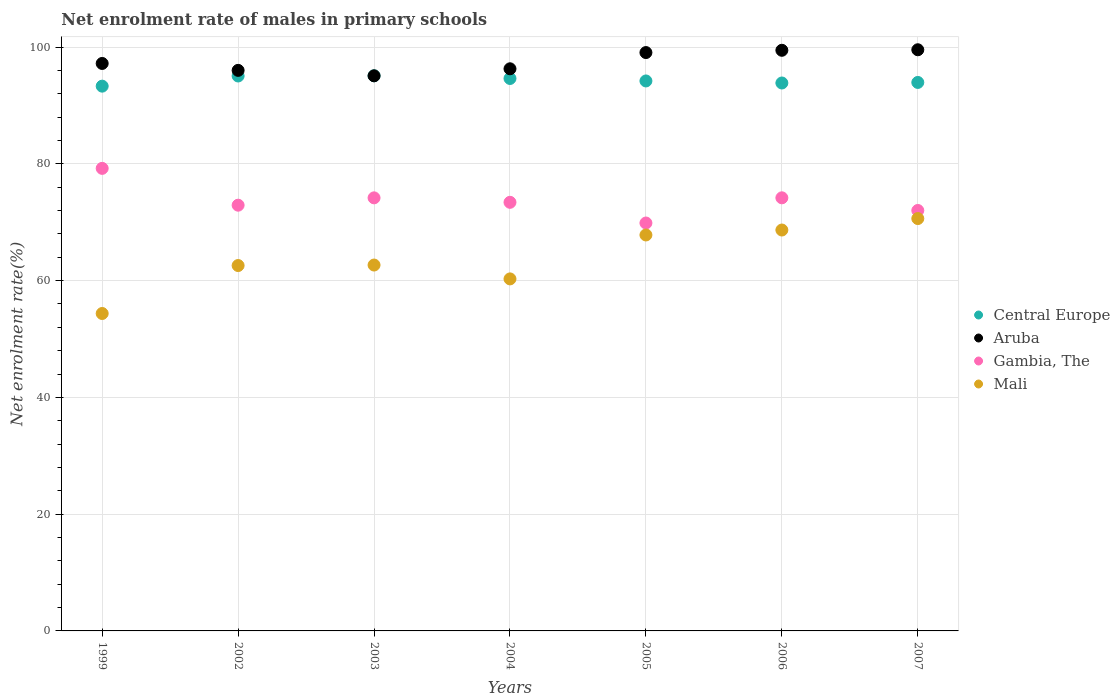Is the number of dotlines equal to the number of legend labels?
Give a very brief answer. Yes. What is the net enrolment rate of males in primary schools in Central Europe in 1999?
Ensure brevity in your answer.  93.31. Across all years, what is the maximum net enrolment rate of males in primary schools in Gambia, The?
Give a very brief answer. 79.23. Across all years, what is the minimum net enrolment rate of males in primary schools in Mali?
Keep it short and to the point. 54.37. In which year was the net enrolment rate of males in primary schools in Central Europe maximum?
Your response must be concise. 2003. In which year was the net enrolment rate of males in primary schools in Gambia, The minimum?
Your answer should be very brief. 2005. What is the total net enrolment rate of males in primary schools in Aruba in the graph?
Offer a terse response. 682.65. What is the difference between the net enrolment rate of males in primary schools in Mali in 2005 and that in 2007?
Provide a succinct answer. -2.81. What is the difference between the net enrolment rate of males in primary schools in Central Europe in 2004 and the net enrolment rate of males in primary schools in Aruba in 2002?
Provide a succinct answer. -1.39. What is the average net enrolment rate of males in primary schools in Gambia, The per year?
Make the answer very short. 73.69. In the year 2004, what is the difference between the net enrolment rate of males in primary schools in Mali and net enrolment rate of males in primary schools in Aruba?
Make the answer very short. -35.99. In how many years, is the net enrolment rate of males in primary schools in Gambia, The greater than 84 %?
Make the answer very short. 0. What is the ratio of the net enrolment rate of males in primary schools in Aruba in 1999 to that in 2006?
Your answer should be compact. 0.98. What is the difference between the highest and the second highest net enrolment rate of males in primary schools in Gambia, The?
Your response must be concise. 5.04. What is the difference between the highest and the lowest net enrolment rate of males in primary schools in Gambia, The?
Keep it short and to the point. 9.36. In how many years, is the net enrolment rate of males in primary schools in Gambia, The greater than the average net enrolment rate of males in primary schools in Gambia, The taken over all years?
Your response must be concise. 3. Is the sum of the net enrolment rate of males in primary schools in Gambia, The in 1999 and 2007 greater than the maximum net enrolment rate of males in primary schools in Central Europe across all years?
Give a very brief answer. Yes. Is it the case that in every year, the sum of the net enrolment rate of males in primary schools in Central Europe and net enrolment rate of males in primary schools in Mali  is greater than the net enrolment rate of males in primary schools in Aruba?
Your answer should be very brief. Yes. How many dotlines are there?
Offer a terse response. 4. How many years are there in the graph?
Your answer should be very brief. 7. What is the difference between two consecutive major ticks on the Y-axis?
Ensure brevity in your answer.  20. Does the graph contain grids?
Keep it short and to the point. Yes. Where does the legend appear in the graph?
Your answer should be compact. Center right. How are the legend labels stacked?
Your answer should be compact. Vertical. What is the title of the graph?
Give a very brief answer. Net enrolment rate of males in primary schools. Does "Liberia" appear as one of the legend labels in the graph?
Your answer should be very brief. No. What is the label or title of the Y-axis?
Provide a succinct answer. Net enrolment rate(%). What is the Net enrolment rate(%) in Central Europe in 1999?
Your answer should be compact. 93.31. What is the Net enrolment rate(%) of Aruba in 1999?
Offer a very short reply. 97.2. What is the Net enrolment rate(%) in Gambia, The in 1999?
Offer a very short reply. 79.23. What is the Net enrolment rate(%) of Mali in 1999?
Your answer should be very brief. 54.37. What is the Net enrolment rate(%) in Central Europe in 2002?
Your answer should be compact. 95.05. What is the Net enrolment rate(%) in Aruba in 2002?
Offer a very short reply. 96.02. What is the Net enrolment rate(%) of Gambia, The in 2002?
Provide a succinct answer. 72.92. What is the Net enrolment rate(%) of Mali in 2002?
Keep it short and to the point. 62.59. What is the Net enrolment rate(%) of Central Europe in 2003?
Ensure brevity in your answer.  95.09. What is the Net enrolment rate(%) of Aruba in 2003?
Your answer should be very brief. 95.08. What is the Net enrolment rate(%) in Gambia, The in 2003?
Ensure brevity in your answer.  74.18. What is the Net enrolment rate(%) of Mali in 2003?
Provide a succinct answer. 62.67. What is the Net enrolment rate(%) in Central Europe in 2004?
Provide a short and direct response. 94.63. What is the Net enrolment rate(%) in Aruba in 2004?
Make the answer very short. 96.29. What is the Net enrolment rate(%) of Gambia, The in 2004?
Keep it short and to the point. 73.42. What is the Net enrolment rate(%) in Mali in 2004?
Give a very brief answer. 60.3. What is the Net enrolment rate(%) in Central Europe in 2005?
Offer a terse response. 94.2. What is the Net enrolment rate(%) in Aruba in 2005?
Provide a short and direct response. 99.07. What is the Net enrolment rate(%) in Gambia, The in 2005?
Keep it short and to the point. 69.87. What is the Net enrolment rate(%) of Mali in 2005?
Your answer should be very brief. 67.82. What is the Net enrolment rate(%) in Central Europe in 2006?
Make the answer very short. 93.85. What is the Net enrolment rate(%) in Aruba in 2006?
Your response must be concise. 99.46. What is the Net enrolment rate(%) in Gambia, The in 2006?
Keep it short and to the point. 74.18. What is the Net enrolment rate(%) in Mali in 2006?
Keep it short and to the point. 68.67. What is the Net enrolment rate(%) of Central Europe in 2007?
Make the answer very short. 93.95. What is the Net enrolment rate(%) in Aruba in 2007?
Your answer should be very brief. 99.55. What is the Net enrolment rate(%) of Gambia, The in 2007?
Offer a very short reply. 72.02. What is the Net enrolment rate(%) of Mali in 2007?
Provide a short and direct response. 70.63. Across all years, what is the maximum Net enrolment rate(%) in Central Europe?
Offer a very short reply. 95.09. Across all years, what is the maximum Net enrolment rate(%) of Aruba?
Offer a terse response. 99.55. Across all years, what is the maximum Net enrolment rate(%) in Gambia, The?
Give a very brief answer. 79.23. Across all years, what is the maximum Net enrolment rate(%) of Mali?
Your response must be concise. 70.63. Across all years, what is the minimum Net enrolment rate(%) of Central Europe?
Your answer should be compact. 93.31. Across all years, what is the minimum Net enrolment rate(%) in Aruba?
Your answer should be very brief. 95.08. Across all years, what is the minimum Net enrolment rate(%) of Gambia, The?
Your response must be concise. 69.87. Across all years, what is the minimum Net enrolment rate(%) of Mali?
Offer a terse response. 54.37. What is the total Net enrolment rate(%) of Central Europe in the graph?
Make the answer very short. 660.09. What is the total Net enrolment rate(%) of Aruba in the graph?
Provide a succinct answer. 682.65. What is the total Net enrolment rate(%) in Gambia, The in the graph?
Offer a very short reply. 515.82. What is the total Net enrolment rate(%) in Mali in the graph?
Keep it short and to the point. 447.05. What is the difference between the Net enrolment rate(%) in Central Europe in 1999 and that in 2002?
Offer a terse response. -1.74. What is the difference between the Net enrolment rate(%) in Aruba in 1999 and that in 2002?
Offer a very short reply. 1.18. What is the difference between the Net enrolment rate(%) of Gambia, The in 1999 and that in 2002?
Your answer should be compact. 6.31. What is the difference between the Net enrolment rate(%) of Mali in 1999 and that in 2002?
Provide a short and direct response. -8.21. What is the difference between the Net enrolment rate(%) of Central Europe in 1999 and that in 2003?
Your answer should be very brief. -1.77. What is the difference between the Net enrolment rate(%) of Aruba in 1999 and that in 2003?
Ensure brevity in your answer.  2.12. What is the difference between the Net enrolment rate(%) in Gambia, The in 1999 and that in 2003?
Provide a short and direct response. 5.05. What is the difference between the Net enrolment rate(%) of Central Europe in 1999 and that in 2004?
Give a very brief answer. -1.32. What is the difference between the Net enrolment rate(%) in Aruba in 1999 and that in 2004?
Offer a very short reply. 0.91. What is the difference between the Net enrolment rate(%) of Gambia, The in 1999 and that in 2004?
Keep it short and to the point. 5.81. What is the difference between the Net enrolment rate(%) in Mali in 1999 and that in 2004?
Offer a very short reply. -5.93. What is the difference between the Net enrolment rate(%) of Central Europe in 1999 and that in 2005?
Offer a terse response. -0.89. What is the difference between the Net enrolment rate(%) of Aruba in 1999 and that in 2005?
Your answer should be compact. -1.87. What is the difference between the Net enrolment rate(%) of Gambia, The in 1999 and that in 2005?
Give a very brief answer. 9.36. What is the difference between the Net enrolment rate(%) of Mali in 1999 and that in 2005?
Your answer should be very brief. -13.45. What is the difference between the Net enrolment rate(%) in Central Europe in 1999 and that in 2006?
Provide a short and direct response. -0.54. What is the difference between the Net enrolment rate(%) in Aruba in 1999 and that in 2006?
Offer a very short reply. -2.25. What is the difference between the Net enrolment rate(%) of Gambia, The in 1999 and that in 2006?
Your answer should be compact. 5.04. What is the difference between the Net enrolment rate(%) in Mali in 1999 and that in 2006?
Your answer should be very brief. -14.3. What is the difference between the Net enrolment rate(%) in Central Europe in 1999 and that in 2007?
Offer a terse response. -0.64. What is the difference between the Net enrolment rate(%) of Aruba in 1999 and that in 2007?
Offer a very short reply. -2.35. What is the difference between the Net enrolment rate(%) in Gambia, The in 1999 and that in 2007?
Your response must be concise. 7.21. What is the difference between the Net enrolment rate(%) in Mali in 1999 and that in 2007?
Ensure brevity in your answer.  -16.26. What is the difference between the Net enrolment rate(%) of Central Europe in 2002 and that in 2003?
Your response must be concise. -0.03. What is the difference between the Net enrolment rate(%) of Aruba in 2002 and that in 2003?
Your answer should be compact. 0.94. What is the difference between the Net enrolment rate(%) in Gambia, The in 2002 and that in 2003?
Ensure brevity in your answer.  -1.26. What is the difference between the Net enrolment rate(%) of Mali in 2002 and that in 2003?
Your answer should be compact. -0.09. What is the difference between the Net enrolment rate(%) of Central Europe in 2002 and that in 2004?
Provide a short and direct response. 0.42. What is the difference between the Net enrolment rate(%) in Aruba in 2002 and that in 2004?
Keep it short and to the point. -0.27. What is the difference between the Net enrolment rate(%) in Gambia, The in 2002 and that in 2004?
Offer a very short reply. -0.49. What is the difference between the Net enrolment rate(%) of Mali in 2002 and that in 2004?
Offer a terse response. 2.29. What is the difference between the Net enrolment rate(%) in Central Europe in 2002 and that in 2005?
Ensure brevity in your answer.  0.85. What is the difference between the Net enrolment rate(%) of Aruba in 2002 and that in 2005?
Your response must be concise. -3.05. What is the difference between the Net enrolment rate(%) in Gambia, The in 2002 and that in 2005?
Your answer should be compact. 3.05. What is the difference between the Net enrolment rate(%) of Mali in 2002 and that in 2005?
Ensure brevity in your answer.  -5.24. What is the difference between the Net enrolment rate(%) of Central Europe in 2002 and that in 2006?
Provide a succinct answer. 1.2. What is the difference between the Net enrolment rate(%) of Aruba in 2002 and that in 2006?
Keep it short and to the point. -3.44. What is the difference between the Net enrolment rate(%) in Gambia, The in 2002 and that in 2006?
Make the answer very short. -1.26. What is the difference between the Net enrolment rate(%) of Mali in 2002 and that in 2006?
Your answer should be very brief. -6.08. What is the difference between the Net enrolment rate(%) in Central Europe in 2002 and that in 2007?
Provide a succinct answer. 1.1. What is the difference between the Net enrolment rate(%) in Aruba in 2002 and that in 2007?
Provide a succinct answer. -3.53. What is the difference between the Net enrolment rate(%) of Gambia, The in 2002 and that in 2007?
Your answer should be compact. 0.91. What is the difference between the Net enrolment rate(%) of Mali in 2002 and that in 2007?
Your response must be concise. -8.05. What is the difference between the Net enrolment rate(%) in Central Europe in 2003 and that in 2004?
Offer a very short reply. 0.46. What is the difference between the Net enrolment rate(%) of Aruba in 2003 and that in 2004?
Your answer should be compact. -1.21. What is the difference between the Net enrolment rate(%) in Gambia, The in 2003 and that in 2004?
Your answer should be compact. 0.76. What is the difference between the Net enrolment rate(%) in Mali in 2003 and that in 2004?
Provide a short and direct response. 2.37. What is the difference between the Net enrolment rate(%) in Central Europe in 2003 and that in 2005?
Offer a very short reply. 0.88. What is the difference between the Net enrolment rate(%) of Aruba in 2003 and that in 2005?
Ensure brevity in your answer.  -3.99. What is the difference between the Net enrolment rate(%) of Gambia, The in 2003 and that in 2005?
Your response must be concise. 4.31. What is the difference between the Net enrolment rate(%) in Mali in 2003 and that in 2005?
Ensure brevity in your answer.  -5.15. What is the difference between the Net enrolment rate(%) of Central Europe in 2003 and that in 2006?
Your answer should be very brief. 1.23. What is the difference between the Net enrolment rate(%) of Aruba in 2003 and that in 2006?
Your response must be concise. -4.37. What is the difference between the Net enrolment rate(%) of Gambia, The in 2003 and that in 2006?
Ensure brevity in your answer.  -0.01. What is the difference between the Net enrolment rate(%) in Mali in 2003 and that in 2006?
Offer a very short reply. -6. What is the difference between the Net enrolment rate(%) of Central Europe in 2003 and that in 2007?
Provide a succinct answer. 1.14. What is the difference between the Net enrolment rate(%) of Aruba in 2003 and that in 2007?
Provide a short and direct response. -4.46. What is the difference between the Net enrolment rate(%) of Gambia, The in 2003 and that in 2007?
Offer a terse response. 2.16. What is the difference between the Net enrolment rate(%) of Mali in 2003 and that in 2007?
Your answer should be very brief. -7.96. What is the difference between the Net enrolment rate(%) in Central Europe in 2004 and that in 2005?
Provide a succinct answer. 0.42. What is the difference between the Net enrolment rate(%) of Aruba in 2004 and that in 2005?
Ensure brevity in your answer.  -2.78. What is the difference between the Net enrolment rate(%) of Gambia, The in 2004 and that in 2005?
Your answer should be very brief. 3.54. What is the difference between the Net enrolment rate(%) of Mali in 2004 and that in 2005?
Provide a succinct answer. -7.52. What is the difference between the Net enrolment rate(%) of Central Europe in 2004 and that in 2006?
Offer a terse response. 0.77. What is the difference between the Net enrolment rate(%) of Aruba in 2004 and that in 2006?
Your answer should be very brief. -3.17. What is the difference between the Net enrolment rate(%) in Gambia, The in 2004 and that in 2006?
Your answer should be compact. -0.77. What is the difference between the Net enrolment rate(%) of Mali in 2004 and that in 2006?
Provide a succinct answer. -8.37. What is the difference between the Net enrolment rate(%) in Central Europe in 2004 and that in 2007?
Your answer should be compact. 0.68. What is the difference between the Net enrolment rate(%) in Aruba in 2004 and that in 2007?
Your answer should be compact. -3.26. What is the difference between the Net enrolment rate(%) of Gambia, The in 2004 and that in 2007?
Offer a terse response. 1.4. What is the difference between the Net enrolment rate(%) in Mali in 2004 and that in 2007?
Provide a succinct answer. -10.34. What is the difference between the Net enrolment rate(%) of Central Europe in 2005 and that in 2006?
Provide a short and direct response. 0.35. What is the difference between the Net enrolment rate(%) of Aruba in 2005 and that in 2006?
Ensure brevity in your answer.  -0.39. What is the difference between the Net enrolment rate(%) of Gambia, The in 2005 and that in 2006?
Your answer should be compact. -4.31. What is the difference between the Net enrolment rate(%) of Mali in 2005 and that in 2006?
Keep it short and to the point. -0.85. What is the difference between the Net enrolment rate(%) of Central Europe in 2005 and that in 2007?
Keep it short and to the point. 0.26. What is the difference between the Net enrolment rate(%) in Aruba in 2005 and that in 2007?
Your answer should be very brief. -0.48. What is the difference between the Net enrolment rate(%) of Gambia, The in 2005 and that in 2007?
Provide a short and direct response. -2.15. What is the difference between the Net enrolment rate(%) in Mali in 2005 and that in 2007?
Keep it short and to the point. -2.81. What is the difference between the Net enrolment rate(%) of Central Europe in 2006 and that in 2007?
Offer a very short reply. -0.09. What is the difference between the Net enrolment rate(%) in Aruba in 2006 and that in 2007?
Your answer should be compact. -0.09. What is the difference between the Net enrolment rate(%) in Gambia, The in 2006 and that in 2007?
Keep it short and to the point. 2.17. What is the difference between the Net enrolment rate(%) in Mali in 2006 and that in 2007?
Provide a succinct answer. -1.96. What is the difference between the Net enrolment rate(%) of Central Europe in 1999 and the Net enrolment rate(%) of Aruba in 2002?
Keep it short and to the point. -2.7. What is the difference between the Net enrolment rate(%) of Central Europe in 1999 and the Net enrolment rate(%) of Gambia, The in 2002?
Your response must be concise. 20.39. What is the difference between the Net enrolment rate(%) in Central Europe in 1999 and the Net enrolment rate(%) in Mali in 2002?
Your response must be concise. 30.73. What is the difference between the Net enrolment rate(%) of Aruba in 1999 and the Net enrolment rate(%) of Gambia, The in 2002?
Keep it short and to the point. 24.28. What is the difference between the Net enrolment rate(%) in Aruba in 1999 and the Net enrolment rate(%) in Mali in 2002?
Your response must be concise. 34.61. What is the difference between the Net enrolment rate(%) in Gambia, The in 1999 and the Net enrolment rate(%) in Mali in 2002?
Provide a succinct answer. 16.64. What is the difference between the Net enrolment rate(%) of Central Europe in 1999 and the Net enrolment rate(%) of Aruba in 2003?
Keep it short and to the point. -1.77. What is the difference between the Net enrolment rate(%) in Central Europe in 1999 and the Net enrolment rate(%) in Gambia, The in 2003?
Provide a succinct answer. 19.13. What is the difference between the Net enrolment rate(%) in Central Europe in 1999 and the Net enrolment rate(%) in Mali in 2003?
Keep it short and to the point. 30.64. What is the difference between the Net enrolment rate(%) in Aruba in 1999 and the Net enrolment rate(%) in Gambia, The in 2003?
Ensure brevity in your answer.  23.02. What is the difference between the Net enrolment rate(%) in Aruba in 1999 and the Net enrolment rate(%) in Mali in 2003?
Keep it short and to the point. 34.53. What is the difference between the Net enrolment rate(%) in Gambia, The in 1999 and the Net enrolment rate(%) in Mali in 2003?
Your answer should be compact. 16.56. What is the difference between the Net enrolment rate(%) in Central Europe in 1999 and the Net enrolment rate(%) in Aruba in 2004?
Keep it short and to the point. -2.97. What is the difference between the Net enrolment rate(%) in Central Europe in 1999 and the Net enrolment rate(%) in Gambia, The in 2004?
Offer a terse response. 19.9. What is the difference between the Net enrolment rate(%) in Central Europe in 1999 and the Net enrolment rate(%) in Mali in 2004?
Keep it short and to the point. 33.01. What is the difference between the Net enrolment rate(%) in Aruba in 1999 and the Net enrolment rate(%) in Gambia, The in 2004?
Your answer should be compact. 23.79. What is the difference between the Net enrolment rate(%) in Aruba in 1999 and the Net enrolment rate(%) in Mali in 2004?
Provide a short and direct response. 36.9. What is the difference between the Net enrolment rate(%) of Gambia, The in 1999 and the Net enrolment rate(%) of Mali in 2004?
Provide a succinct answer. 18.93. What is the difference between the Net enrolment rate(%) of Central Europe in 1999 and the Net enrolment rate(%) of Aruba in 2005?
Keep it short and to the point. -5.75. What is the difference between the Net enrolment rate(%) of Central Europe in 1999 and the Net enrolment rate(%) of Gambia, The in 2005?
Provide a succinct answer. 23.44. What is the difference between the Net enrolment rate(%) in Central Europe in 1999 and the Net enrolment rate(%) in Mali in 2005?
Provide a succinct answer. 25.49. What is the difference between the Net enrolment rate(%) of Aruba in 1999 and the Net enrolment rate(%) of Gambia, The in 2005?
Provide a short and direct response. 27.33. What is the difference between the Net enrolment rate(%) in Aruba in 1999 and the Net enrolment rate(%) in Mali in 2005?
Give a very brief answer. 29.38. What is the difference between the Net enrolment rate(%) in Gambia, The in 1999 and the Net enrolment rate(%) in Mali in 2005?
Make the answer very short. 11.41. What is the difference between the Net enrolment rate(%) of Central Europe in 1999 and the Net enrolment rate(%) of Aruba in 2006?
Keep it short and to the point. -6.14. What is the difference between the Net enrolment rate(%) in Central Europe in 1999 and the Net enrolment rate(%) in Gambia, The in 2006?
Your answer should be very brief. 19.13. What is the difference between the Net enrolment rate(%) in Central Europe in 1999 and the Net enrolment rate(%) in Mali in 2006?
Ensure brevity in your answer.  24.64. What is the difference between the Net enrolment rate(%) of Aruba in 1999 and the Net enrolment rate(%) of Gambia, The in 2006?
Provide a succinct answer. 23.02. What is the difference between the Net enrolment rate(%) of Aruba in 1999 and the Net enrolment rate(%) of Mali in 2006?
Your response must be concise. 28.53. What is the difference between the Net enrolment rate(%) in Gambia, The in 1999 and the Net enrolment rate(%) in Mali in 2006?
Your response must be concise. 10.56. What is the difference between the Net enrolment rate(%) in Central Europe in 1999 and the Net enrolment rate(%) in Aruba in 2007?
Your response must be concise. -6.23. What is the difference between the Net enrolment rate(%) of Central Europe in 1999 and the Net enrolment rate(%) of Gambia, The in 2007?
Keep it short and to the point. 21.29. What is the difference between the Net enrolment rate(%) in Central Europe in 1999 and the Net enrolment rate(%) in Mali in 2007?
Your response must be concise. 22.68. What is the difference between the Net enrolment rate(%) in Aruba in 1999 and the Net enrolment rate(%) in Gambia, The in 2007?
Offer a terse response. 25.18. What is the difference between the Net enrolment rate(%) in Aruba in 1999 and the Net enrolment rate(%) in Mali in 2007?
Keep it short and to the point. 26.57. What is the difference between the Net enrolment rate(%) in Gambia, The in 1999 and the Net enrolment rate(%) in Mali in 2007?
Give a very brief answer. 8.6. What is the difference between the Net enrolment rate(%) of Central Europe in 2002 and the Net enrolment rate(%) of Aruba in 2003?
Ensure brevity in your answer.  -0.03. What is the difference between the Net enrolment rate(%) of Central Europe in 2002 and the Net enrolment rate(%) of Gambia, The in 2003?
Make the answer very short. 20.87. What is the difference between the Net enrolment rate(%) of Central Europe in 2002 and the Net enrolment rate(%) of Mali in 2003?
Your answer should be compact. 32.38. What is the difference between the Net enrolment rate(%) of Aruba in 2002 and the Net enrolment rate(%) of Gambia, The in 2003?
Keep it short and to the point. 21.84. What is the difference between the Net enrolment rate(%) of Aruba in 2002 and the Net enrolment rate(%) of Mali in 2003?
Keep it short and to the point. 33.35. What is the difference between the Net enrolment rate(%) of Gambia, The in 2002 and the Net enrolment rate(%) of Mali in 2003?
Make the answer very short. 10.25. What is the difference between the Net enrolment rate(%) in Central Europe in 2002 and the Net enrolment rate(%) in Aruba in 2004?
Keep it short and to the point. -1.23. What is the difference between the Net enrolment rate(%) in Central Europe in 2002 and the Net enrolment rate(%) in Gambia, The in 2004?
Your answer should be compact. 21.64. What is the difference between the Net enrolment rate(%) of Central Europe in 2002 and the Net enrolment rate(%) of Mali in 2004?
Provide a short and direct response. 34.75. What is the difference between the Net enrolment rate(%) in Aruba in 2002 and the Net enrolment rate(%) in Gambia, The in 2004?
Offer a terse response. 22.6. What is the difference between the Net enrolment rate(%) in Aruba in 2002 and the Net enrolment rate(%) in Mali in 2004?
Your response must be concise. 35.72. What is the difference between the Net enrolment rate(%) in Gambia, The in 2002 and the Net enrolment rate(%) in Mali in 2004?
Offer a very short reply. 12.62. What is the difference between the Net enrolment rate(%) in Central Europe in 2002 and the Net enrolment rate(%) in Aruba in 2005?
Your response must be concise. -4.01. What is the difference between the Net enrolment rate(%) in Central Europe in 2002 and the Net enrolment rate(%) in Gambia, The in 2005?
Provide a short and direct response. 25.18. What is the difference between the Net enrolment rate(%) of Central Europe in 2002 and the Net enrolment rate(%) of Mali in 2005?
Ensure brevity in your answer.  27.23. What is the difference between the Net enrolment rate(%) of Aruba in 2002 and the Net enrolment rate(%) of Gambia, The in 2005?
Make the answer very short. 26.15. What is the difference between the Net enrolment rate(%) of Aruba in 2002 and the Net enrolment rate(%) of Mali in 2005?
Your answer should be very brief. 28.2. What is the difference between the Net enrolment rate(%) of Gambia, The in 2002 and the Net enrolment rate(%) of Mali in 2005?
Offer a terse response. 5.1. What is the difference between the Net enrolment rate(%) in Central Europe in 2002 and the Net enrolment rate(%) in Aruba in 2006?
Provide a succinct answer. -4.4. What is the difference between the Net enrolment rate(%) in Central Europe in 2002 and the Net enrolment rate(%) in Gambia, The in 2006?
Provide a succinct answer. 20.87. What is the difference between the Net enrolment rate(%) of Central Europe in 2002 and the Net enrolment rate(%) of Mali in 2006?
Offer a very short reply. 26.38. What is the difference between the Net enrolment rate(%) in Aruba in 2002 and the Net enrolment rate(%) in Gambia, The in 2006?
Make the answer very short. 21.83. What is the difference between the Net enrolment rate(%) in Aruba in 2002 and the Net enrolment rate(%) in Mali in 2006?
Your answer should be very brief. 27.35. What is the difference between the Net enrolment rate(%) of Gambia, The in 2002 and the Net enrolment rate(%) of Mali in 2006?
Ensure brevity in your answer.  4.25. What is the difference between the Net enrolment rate(%) of Central Europe in 2002 and the Net enrolment rate(%) of Aruba in 2007?
Make the answer very short. -4.49. What is the difference between the Net enrolment rate(%) of Central Europe in 2002 and the Net enrolment rate(%) of Gambia, The in 2007?
Provide a succinct answer. 23.03. What is the difference between the Net enrolment rate(%) of Central Europe in 2002 and the Net enrolment rate(%) of Mali in 2007?
Offer a very short reply. 24.42. What is the difference between the Net enrolment rate(%) of Aruba in 2002 and the Net enrolment rate(%) of Gambia, The in 2007?
Provide a short and direct response. 24. What is the difference between the Net enrolment rate(%) in Aruba in 2002 and the Net enrolment rate(%) in Mali in 2007?
Keep it short and to the point. 25.38. What is the difference between the Net enrolment rate(%) of Gambia, The in 2002 and the Net enrolment rate(%) of Mali in 2007?
Keep it short and to the point. 2.29. What is the difference between the Net enrolment rate(%) of Central Europe in 2003 and the Net enrolment rate(%) of Aruba in 2004?
Keep it short and to the point. -1.2. What is the difference between the Net enrolment rate(%) of Central Europe in 2003 and the Net enrolment rate(%) of Gambia, The in 2004?
Give a very brief answer. 21.67. What is the difference between the Net enrolment rate(%) in Central Europe in 2003 and the Net enrolment rate(%) in Mali in 2004?
Keep it short and to the point. 34.79. What is the difference between the Net enrolment rate(%) of Aruba in 2003 and the Net enrolment rate(%) of Gambia, The in 2004?
Your response must be concise. 21.67. What is the difference between the Net enrolment rate(%) of Aruba in 2003 and the Net enrolment rate(%) of Mali in 2004?
Your answer should be very brief. 34.78. What is the difference between the Net enrolment rate(%) in Gambia, The in 2003 and the Net enrolment rate(%) in Mali in 2004?
Ensure brevity in your answer.  13.88. What is the difference between the Net enrolment rate(%) in Central Europe in 2003 and the Net enrolment rate(%) in Aruba in 2005?
Keep it short and to the point. -3.98. What is the difference between the Net enrolment rate(%) in Central Europe in 2003 and the Net enrolment rate(%) in Gambia, The in 2005?
Ensure brevity in your answer.  25.22. What is the difference between the Net enrolment rate(%) in Central Europe in 2003 and the Net enrolment rate(%) in Mali in 2005?
Your answer should be very brief. 27.26. What is the difference between the Net enrolment rate(%) of Aruba in 2003 and the Net enrolment rate(%) of Gambia, The in 2005?
Provide a short and direct response. 25.21. What is the difference between the Net enrolment rate(%) in Aruba in 2003 and the Net enrolment rate(%) in Mali in 2005?
Keep it short and to the point. 27.26. What is the difference between the Net enrolment rate(%) of Gambia, The in 2003 and the Net enrolment rate(%) of Mali in 2005?
Your response must be concise. 6.36. What is the difference between the Net enrolment rate(%) of Central Europe in 2003 and the Net enrolment rate(%) of Aruba in 2006?
Your answer should be very brief. -4.37. What is the difference between the Net enrolment rate(%) of Central Europe in 2003 and the Net enrolment rate(%) of Gambia, The in 2006?
Offer a very short reply. 20.9. What is the difference between the Net enrolment rate(%) of Central Europe in 2003 and the Net enrolment rate(%) of Mali in 2006?
Your response must be concise. 26.42. What is the difference between the Net enrolment rate(%) of Aruba in 2003 and the Net enrolment rate(%) of Gambia, The in 2006?
Your response must be concise. 20.9. What is the difference between the Net enrolment rate(%) of Aruba in 2003 and the Net enrolment rate(%) of Mali in 2006?
Offer a terse response. 26.41. What is the difference between the Net enrolment rate(%) of Gambia, The in 2003 and the Net enrolment rate(%) of Mali in 2006?
Keep it short and to the point. 5.51. What is the difference between the Net enrolment rate(%) of Central Europe in 2003 and the Net enrolment rate(%) of Aruba in 2007?
Provide a succinct answer. -4.46. What is the difference between the Net enrolment rate(%) in Central Europe in 2003 and the Net enrolment rate(%) in Gambia, The in 2007?
Provide a succinct answer. 23.07. What is the difference between the Net enrolment rate(%) in Central Europe in 2003 and the Net enrolment rate(%) in Mali in 2007?
Provide a succinct answer. 24.45. What is the difference between the Net enrolment rate(%) of Aruba in 2003 and the Net enrolment rate(%) of Gambia, The in 2007?
Ensure brevity in your answer.  23.06. What is the difference between the Net enrolment rate(%) in Aruba in 2003 and the Net enrolment rate(%) in Mali in 2007?
Offer a very short reply. 24.45. What is the difference between the Net enrolment rate(%) of Gambia, The in 2003 and the Net enrolment rate(%) of Mali in 2007?
Keep it short and to the point. 3.55. What is the difference between the Net enrolment rate(%) in Central Europe in 2004 and the Net enrolment rate(%) in Aruba in 2005?
Offer a very short reply. -4.44. What is the difference between the Net enrolment rate(%) in Central Europe in 2004 and the Net enrolment rate(%) in Gambia, The in 2005?
Provide a short and direct response. 24.76. What is the difference between the Net enrolment rate(%) of Central Europe in 2004 and the Net enrolment rate(%) of Mali in 2005?
Offer a very short reply. 26.81. What is the difference between the Net enrolment rate(%) of Aruba in 2004 and the Net enrolment rate(%) of Gambia, The in 2005?
Make the answer very short. 26.42. What is the difference between the Net enrolment rate(%) of Aruba in 2004 and the Net enrolment rate(%) of Mali in 2005?
Offer a terse response. 28.46. What is the difference between the Net enrolment rate(%) in Gambia, The in 2004 and the Net enrolment rate(%) in Mali in 2005?
Make the answer very short. 5.59. What is the difference between the Net enrolment rate(%) of Central Europe in 2004 and the Net enrolment rate(%) of Aruba in 2006?
Give a very brief answer. -4.83. What is the difference between the Net enrolment rate(%) of Central Europe in 2004 and the Net enrolment rate(%) of Gambia, The in 2006?
Offer a terse response. 20.44. What is the difference between the Net enrolment rate(%) of Central Europe in 2004 and the Net enrolment rate(%) of Mali in 2006?
Keep it short and to the point. 25.96. What is the difference between the Net enrolment rate(%) in Aruba in 2004 and the Net enrolment rate(%) in Gambia, The in 2006?
Provide a succinct answer. 22.1. What is the difference between the Net enrolment rate(%) of Aruba in 2004 and the Net enrolment rate(%) of Mali in 2006?
Offer a very short reply. 27.62. What is the difference between the Net enrolment rate(%) in Gambia, The in 2004 and the Net enrolment rate(%) in Mali in 2006?
Provide a short and direct response. 4.75. What is the difference between the Net enrolment rate(%) in Central Europe in 2004 and the Net enrolment rate(%) in Aruba in 2007?
Provide a short and direct response. -4.92. What is the difference between the Net enrolment rate(%) in Central Europe in 2004 and the Net enrolment rate(%) in Gambia, The in 2007?
Offer a terse response. 22.61. What is the difference between the Net enrolment rate(%) of Central Europe in 2004 and the Net enrolment rate(%) of Mali in 2007?
Ensure brevity in your answer.  23.99. What is the difference between the Net enrolment rate(%) of Aruba in 2004 and the Net enrolment rate(%) of Gambia, The in 2007?
Ensure brevity in your answer.  24.27. What is the difference between the Net enrolment rate(%) in Aruba in 2004 and the Net enrolment rate(%) in Mali in 2007?
Offer a terse response. 25.65. What is the difference between the Net enrolment rate(%) of Gambia, The in 2004 and the Net enrolment rate(%) of Mali in 2007?
Your response must be concise. 2.78. What is the difference between the Net enrolment rate(%) in Central Europe in 2005 and the Net enrolment rate(%) in Aruba in 2006?
Make the answer very short. -5.25. What is the difference between the Net enrolment rate(%) of Central Europe in 2005 and the Net enrolment rate(%) of Gambia, The in 2006?
Offer a terse response. 20.02. What is the difference between the Net enrolment rate(%) in Central Europe in 2005 and the Net enrolment rate(%) in Mali in 2006?
Offer a very short reply. 25.53. What is the difference between the Net enrolment rate(%) in Aruba in 2005 and the Net enrolment rate(%) in Gambia, The in 2006?
Your response must be concise. 24.88. What is the difference between the Net enrolment rate(%) of Aruba in 2005 and the Net enrolment rate(%) of Mali in 2006?
Offer a very short reply. 30.4. What is the difference between the Net enrolment rate(%) of Gambia, The in 2005 and the Net enrolment rate(%) of Mali in 2006?
Ensure brevity in your answer.  1.2. What is the difference between the Net enrolment rate(%) of Central Europe in 2005 and the Net enrolment rate(%) of Aruba in 2007?
Ensure brevity in your answer.  -5.34. What is the difference between the Net enrolment rate(%) in Central Europe in 2005 and the Net enrolment rate(%) in Gambia, The in 2007?
Your answer should be compact. 22.19. What is the difference between the Net enrolment rate(%) of Central Europe in 2005 and the Net enrolment rate(%) of Mali in 2007?
Keep it short and to the point. 23.57. What is the difference between the Net enrolment rate(%) of Aruba in 2005 and the Net enrolment rate(%) of Gambia, The in 2007?
Provide a succinct answer. 27.05. What is the difference between the Net enrolment rate(%) in Aruba in 2005 and the Net enrolment rate(%) in Mali in 2007?
Provide a short and direct response. 28.43. What is the difference between the Net enrolment rate(%) in Gambia, The in 2005 and the Net enrolment rate(%) in Mali in 2007?
Keep it short and to the point. -0.76. What is the difference between the Net enrolment rate(%) in Central Europe in 2006 and the Net enrolment rate(%) in Aruba in 2007?
Offer a terse response. -5.69. What is the difference between the Net enrolment rate(%) of Central Europe in 2006 and the Net enrolment rate(%) of Gambia, The in 2007?
Your answer should be very brief. 21.84. What is the difference between the Net enrolment rate(%) of Central Europe in 2006 and the Net enrolment rate(%) of Mali in 2007?
Your answer should be very brief. 23.22. What is the difference between the Net enrolment rate(%) of Aruba in 2006 and the Net enrolment rate(%) of Gambia, The in 2007?
Make the answer very short. 27.44. What is the difference between the Net enrolment rate(%) of Aruba in 2006 and the Net enrolment rate(%) of Mali in 2007?
Give a very brief answer. 28.82. What is the difference between the Net enrolment rate(%) of Gambia, The in 2006 and the Net enrolment rate(%) of Mali in 2007?
Make the answer very short. 3.55. What is the average Net enrolment rate(%) in Central Europe per year?
Offer a very short reply. 94.3. What is the average Net enrolment rate(%) in Aruba per year?
Offer a very short reply. 97.52. What is the average Net enrolment rate(%) of Gambia, The per year?
Provide a succinct answer. 73.69. What is the average Net enrolment rate(%) in Mali per year?
Give a very brief answer. 63.86. In the year 1999, what is the difference between the Net enrolment rate(%) of Central Europe and Net enrolment rate(%) of Aruba?
Offer a very short reply. -3.89. In the year 1999, what is the difference between the Net enrolment rate(%) of Central Europe and Net enrolment rate(%) of Gambia, The?
Your answer should be compact. 14.08. In the year 1999, what is the difference between the Net enrolment rate(%) of Central Europe and Net enrolment rate(%) of Mali?
Offer a terse response. 38.94. In the year 1999, what is the difference between the Net enrolment rate(%) of Aruba and Net enrolment rate(%) of Gambia, The?
Ensure brevity in your answer.  17.97. In the year 1999, what is the difference between the Net enrolment rate(%) in Aruba and Net enrolment rate(%) in Mali?
Give a very brief answer. 42.83. In the year 1999, what is the difference between the Net enrolment rate(%) of Gambia, The and Net enrolment rate(%) of Mali?
Ensure brevity in your answer.  24.86. In the year 2002, what is the difference between the Net enrolment rate(%) in Central Europe and Net enrolment rate(%) in Aruba?
Give a very brief answer. -0.97. In the year 2002, what is the difference between the Net enrolment rate(%) in Central Europe and Net enrolment rate(%) in Gambia, The?
Your answer should be compact. 22.13. In the year 2002, what is the difference between the Net enrolment rate(%) in Central Europe and Net enrolment rate(%) in Mali?
Keep it short and to the point. 32.47. In the year 2002, what is the difference between the Net enrolment rate(%) of Aruba and Net enrolment rate(%) of Gambia, The?
Offer a very short reply. 23.09. In the year 2002, what is the difference between the Net enrolment rate(%) of Aruba and Net enrolment rate(%) of Mali?
Offer a terse response. 33.43. In the year 2002, what is the difference between the Net enrolment rate(%) in Gambia, The and Net enrolment rate(%) in Mali?
Your response must be concise. 10.34. In the year 2003, what is the difference between the Net enrolment rate(%) of Central Europe and Net enrolment rate(%) of Aruba?
Make the answer very short. 0.01. In the year 2003, what is the difference between the Net enrolment rate(%) of Central Europe and Net enrolment rate(%) of Gambia, The?
Your answer should be very brief. 20.91. In the year 2003, what is the difference between the Net enrolment rate(%) in Central Europe and Net enrolment rate(%) in Mali?
Your response must be concise. 32.42. In the year 2003, what is the difference between the Net enrolment rate(%) in Aruba and Net enrolment rate(%) in Gambia, The?
Give a very brief answer. 20.9. In the year 2003, what is the difference between the Net enrolment rate(%) in Aruba and Net enrolment rate(%) in Mali?
Ensure brevity in your answer.  32.41. In the year 2003, what is the difference between the Net enrolment rate(%) of Gambia, The and Net enrolment rate(%) of Mali?
Give a very brief answer. 11.51. In the year 2004, what is the difference between the Net enrolment rate(%) in Central Europe and Net enrolment rate(%) in Aruba?
Provide a short and direct response. -1.66. In the year 2004, what is the difference between the Net enrolment rate(%) of Central Europe and Net enrolment rate(%) of Gambia, The?
Ensure brevity in your answer.  21.21. In the year 2004, what is the difference between the Net enrolment rate(%) of Central Europe and Net enrolment rate(%) of Mali?
Make the answer very short. 34.33. In the year 2004, what is the difference between the Net enrolment rate(%) of Aruba and Net enrolment rate(%) of Gambia, The?
Your answer should be compact. 22.87. In the year 2004, what is the difference between the Net enrolment rate(%) in Aruba and Net enrolment rate(%) in Mali?
Give a very brief answer. 35.99. In the year 2004, what is the difference between the Net enrolment rate(%) in Gambia, The and Net enrolment rate(%) in Mali?
Give a very brief answer. 13.12. In the year 2005, what is the difference between the Net enrolment rate(%) of Central Europe and Net enrolment rate(%) of Aruba?
Ensure brevity in your answer.  -4.86. In the year 2005, what is the difference between the Net enrolment rate(%) in Central Europe and Net enrolment rate(%) in Gambia, The?
Provide a succinct answer. 24.33. In the year 2005, what is the difference between the Net enrolment rate(%) of Central Europe and Net enrolment rate(%) of Mali?
Ensure brevity in your answer.  26.38. In the year 2005, what is the difference between the Net enrolment rate(%) in Aruba and Net enrolment rate(%) in Gambia, The?
Offer a terse response. 29.2. In the year 2005, what is the difference between the Net enrolment rate(%) in Aruba and Net enrolment rate(%) in Mali?
Your response must be concise. 31.24. In the year 2005, what is the difference between the Net enrolment rate(%) of Gambia, The and Net enrolment rate(%) of Mali?
Make the answer very short. 2.05. In the year 2006, what is the difference between the Net enrolment rate(%) in Central Europe and Net enrolment rate(%) in Aruba?
Offer a very short reply. -5.6. In the year 2006, what is the difference between the Net enrolment rate(%) of Central Europe and Net enrolment rate(%) of Gambia, The?
Give a very brief answer. 19.67. In the year 2006, what is the difference between the Net enrolment rate(%) in Central Europe and Net enrolment rate(%) in Mali?
Offer a terse response. 25.18. In the year 2006, what is the difference between the Net enrolment rate(%) of Aruba and Net enrolment rate(%) of Gambia, The?
Your answer should be compact. 25.27. In the year 2006, what is the difference between the Net enrolment rate(%) in Aruba and Net enrolment rate(%) in Mali?
Provide a succinct answer. 30.79. In the year 2006, what is the difference between the Net enrolment rate(%) in Gambia, The and Net enrolment rate(%) in Mali?
Your answer should be compact. 5.52. In the year 2007, what is the difference between the Net enrolment rate(%) in Central Europe and Net enrolment rate(%) in Aruba?
Give a very brief answer. -5.6. In the year 2007, what is the difference between the Net enrolment rate(%) of Central Europe and Net enrolment rate(%) of Gambia, The?
Keep it short and to the point. 21.93. In the year 2007, what is the difference between the Net enrolment rate(%) in Central Europe and Net enrolment rate(%) in Mali?
Offer a very short reply. 23.32. In the year 2007, what is the difference between the Net enrolment rate(%) of Aruba and Net enrolment rate(%) of Gambia, The?
Ensure brevity in your answer.  27.53. In the year 2007, what is the difference between the Net enrolment rate(%) of Aruba and Net enrolment rate(%) of Mali?
Your answer should be very brief. 28.91. In the year 2007, what is the difference between the Net enrolment rate(%) in Gambia, The and Net enrolment rate(%) in Mali?
Provide a succinct answer. 1.38. What is the ratio of the Net enrolment rate(%) in Central Europe in 1999 to that in 2002?
Make the answer very short. 0.98. What is the ratio of the Net enrolment rate(%) in Aruba in 1999 to that in 2002?
Make the answer very short. 1.01. What is the ratio of the Net enrolment rate(%) of Gambia, The in 1999 to that in 2002?
Your answer should be compact. 1.09. What is the ratio of the Net enrolment rate(%) in Mali in 1999 to that in 2002?
Provide a succinct answer. 0.87. What is the ratio of the Net enrolment rate(%) of Central Europe in 1999 to that in 2003?
Offer a very short reply. 0.98. What is the ratio of the Net enrolment rate(%) of Aruba in 1999 to that in 2003?
Your answer should be compact. 1.02. What is the ratio of the Net enrolment rate(%) in Gambia, The in 1999 to that in 2003?
Keep it short and to the point. 1.07. What is the ratio of the Net enrolment rate(%) of Mali in 1999 to that in 2003?
Make the answer very short. 0.87. What is the ratio of the Net enrolment rate(%) in Central Europe in 1999 to that in 2004?
Your answer should be compact. 0.99. What is the ratio of the Net enrolment rate(%) in Aruba in 1999 to that in 2004?
Offer a very short reply. 1.01. What is the ratio of the Net enrolment rate(%) in Gambia, The in 1999 to that in 2004?
Keep it short and to the point. 1.08. What is the ratio of the Net enrolment rate(%) in Mali in 1999 to that in 2004?
Give a very brief answer. 0.9. What is the ratio of the Net enrolment rate(%) of Central Europe in 1999 to that in 2005?
Give a very brief answer. 0.99. What is the ratio of the Net enrolment rate(%) of Aruba in 1999 to that in 2005?
Offer a very short reply. 0.98. What is the ratio of the Net enrolment rate(%) in Gambia, The in 1999 to that in 2005?
Provide a succinct answer. 1.13. What is the ratio of the Net enrolment rate(%) in Mali in 1999 to that in 2005?
Offer a terse response. 0.8. What is the ratio of the Net enrolment rate(%) of Aruba in 1999 to that in 2006?
Make the answer very short. 0.98. What is the ratio of the Net enrolment rate(%) of Gambia, The in 1999 to that in 2006?
Provide a succinct answer. 1.07. What is the ratio of the Net enrolment rate(%) in Mali in 1999 to that in 2006?
Your response must be concise. 0.79. What is the ratio of the Net enrolment rate(%) in Aruba in 1999 to that in 2007?
Your response must be concise. 0.98. What is the ratio of the Net enrolment rate(%) in Gambia, The in 1999 to that in 2007?
Offer a very short reply. 1.1. What is the ratio of the Net enrolment rate(%) in Mali in 1999 to that in 2007?
Make the answer very short. 0.77. What is the ratio of the Net enrolment rate(%) of Central Europe in 2002 to that in 2003?
Your answer should be very brief. 1. What is the ratio of the Net enrolment rate(%) of Aruba in 2002 to that in 2003?
Provide a short and direct response. 1.01. What is the ratio of the Net enrolment rate(%) of Gambia, The in 2002 to that in 2003?
Your answer should be very brief. 0.98. What is the ratio of the Net enrolment rate(%) in Aruba in 2002 to that in 2004?
Make the answer very short. 1. What is the ratio of the Net enrolment rate(%) in Mali in 2002 to that in 2004?
Make the answer very short. 1.04. What is the ratio of the Net enrolment rate(%) of Central Europe in 2002 to that in 2005?
Provide a succinct answer. 1.01. What is the ratio of the Net enrolment rate(%) of Aruba in 2002 to that in 2005?
Keep it short and to the point. 0.97. What is the ratio of the Net enrolment rate(%) in Gambia, The in 2002 to that in 2005?
Provide a short and direct response. 1.04. What is the ratio of the Net enrolment rate(%) in Mali in 2002 to that in 2005?
Offer a terse response. 0.92. What is the ratio of the Net enrolment rate(%) in Central Europe in 2002 to that in 2006?
Provide a succinct answer. 1.01. What is the ratio of the Net enrolment rate(%) in Aruba in 2002 to that in 2006?
Provide a short and direct response. 0.97. What is the ratio of the Net enrolment rate(%) in Gambia, The in 2002 to that in 2006?
Your answer should be compact. 0.98. What is the ratio of the Net enrolment rate(%) of Mali in 2002 to that in 2006?
Ensure brevity in your answer.  0.91. What is the ratio of the Net enrolment rate(%) of Central Europe in 2002 to that in 2007?
Make the answer very short. 1.01. What is the ratio of the Net enrolment rate(%) of Aruba in 2002 to that in 2007?
Provide a succinct answer. 0.96. What is the ratio of the Net enrolment rate(%) in Gambia, The in 2002 to that in 2007?
Your answer should be compact. 1.01. What is the ratio of the Net enrolment rate(%) of Mali in 2002 to that in 2007?
Your answer should be very brief. 0.89. What is the ratio of the Net enrolment rate(%) of Central Europe in 2003 to that in 2004?
Offer a terse response. 1. What is the ratio of the Net enrolment rate(%) of Aruba in 2003 to that in 2004?
Your answer should be compact. 0.99. What is the ratio of the Net enrolment rate(%) in Gambia, The in 2003 to that in 2004?
Offer a very short reply. 1.01. What is the ratio of the Net enrolment rate(%) in Mali in 2003 to that in 2004?
Offer a very short reply. 1.04. What is the ratio of the Net enrolment rate(%) of Central Europe in 2003 to that in 2005?
Your answer should be very brief. 1.01. What is the ratio of the Net enrolment rate(%) in Aruba in 2003 to that in 2005?
Offer a very short reply. 0.96. What is the ratio of the Net enrolment rate(%) in Gambia, The in 2003 to that in 2005?
Your response must be concise. 1.06. What is the ratio of the Net enrolment rate(%) in Mali in 2003 to that in 2005?
Ensure brevity in your answer.  0.92. What is the ratio of the Net enrolment rate(%) in Central Europe in 2003 to that in 2006?
Offer a terse response. 1.01. What is the ratio of the Net enrolment rate(%) of Aruba in 2003 to that in 2006?
Give a very brief answer. 0.96. What is the ratio of the Net enrolment rate(%) in Mali in 2003 to that in 2006?
Make the answer very short. 0.91. What is the ratio of the Net enrolment rate(%) in Central Europe in 2003 to that in 2007?
Give a very brief answer. 1.01. What is the ratio of the Net enrolment rate(%) in Aruba in 2003 to that in 2007?
Your answer should be very brief. 0.96. What is the ratio of the Net enrolment rate(%) of Gambia, The in 2003 to that in 2007?
Offer a very short reply. 1.03. What is the ratio of the Net enrolment rate(%) of Mali in 2003 to that in 2007?
Ensure brevity in your answer.  0.89. What is the ratio of the Net enrolment rate(%) of Aruba in 2004 to that in 2005?
Provide a succinct answer. 0.97. What is the ratio of the Net enrolment rate(%) of Gambia, The in 2004 to that in 2005?
Your response must be concise. 1.05. What is the ratio of the Net enrolment rate(%) of Mali in 2004 to that in 2005?
Make the answer very short. 0.89. What is the ratio of the Net enrolment rate(%) in Central Europe in 2004 to that in 2006?
Provide a short and direct response. 1.01. What is the ratio of the Net enrolment rate(%) of Aruba in 2004 to that in 2006?
Offer a terse response. 0.97. What is the ratio of the Net enrolment rate(%) in Gambia, The in 2004 to that in 2006?
Provide a succinct answer. 0.99. What is the ratio of the Net enrolment rate(%) of Mali in 2004 to that in 2006?
Ensure brevity in your answer.  0.88. What is the ratio of the Net enrolment rate(%) of Central Europe in 2004 to that in 2007?
Your answer should be compact. 1.01. What is the ratio of the Net enrolment rate(%) of Aruba in 2004 to that in 2007?
Provide a succinct answer. 0.97. What is the ratio of the Net enrolment rate(%) in Gambia, The in 2004 to that in 2007?
Give a very brief answer. 1.02. What is the ratio of the Net enrolment rate(%) in Mali in 2004 to that in 2007?
Offer a very short reply. 0.85. What is the ratio of the Net enrolment rate(%) in Central Europe in 2005 to that in 2006?
Provide a short and direct response. 1. What is the ratio of the Net enrolment rate(%) in Gambia, The in 2005 to that in 2006?
Make the answer very short. 0.94. What is the ratio of the Net enrolment rate(%) in Aruba in 2005 to that in 2007?
Your response must be concise. 1. What is the ratio of the Net enrolment rate(%) of Gambia, The in 2005 to that in 2007?
Ensure brevity in your answer.  0.97. What is the ratio of the Net enrolment rate(%) in Mali in 2005 to that in 2007?
Your answer should be very brief. 0.96. What is the ratio of the Net enrolment rate(%) in Central Europe in 2006 to that in 2007?
Make the answer very short. 1. What is the ratio of the Net enrolment rate(%) in Aruba in 2006 to that in 2007?
Provide a succinct answer. 1. What is the ratio of the Net enrolment rate(%) of Gambia, The in 2006 to that in 2007?
Your response must be concise. 1.03. What is the ratio of the Net enrolment rate(%) in Mali in 2006 to that in 2007?
Provide a succinct answer. 0.97. What is the difference between the highest and the second highest Net enrolment rate(%) in Central Europe?
Your answer should be very brief. 0.03. What is the difference between the highest and the second highest Net enrolment rate(%) of Aruba?
Give a very brief answer. 0.09. What is the difference between the highest and the second highest Net enrolment rate(%) of Gambia, The?
Provide a short and direct response. 5.04. What is the difference between the highest and the second highest Net enrolment rate(%) of Mali?
Provide a short and direct response. 1.96. What is the difference between the highest and the lowest Net enrolment rate(%) in Central Europe?
Make the answer very short. 1.77. What is the difference between the highest and the lowest Net enrolment rate(%) in Aruba?
Your response must be concise. 4.46. What is the difference between the highest and the lowest Net enrolment rate(%) in Gambia, The?
Give a very brief answer. 9.36. What is the difference between the highest and the lowest Net enrolment rate(%) in Mali?
Offer a terse response. 16.26. 